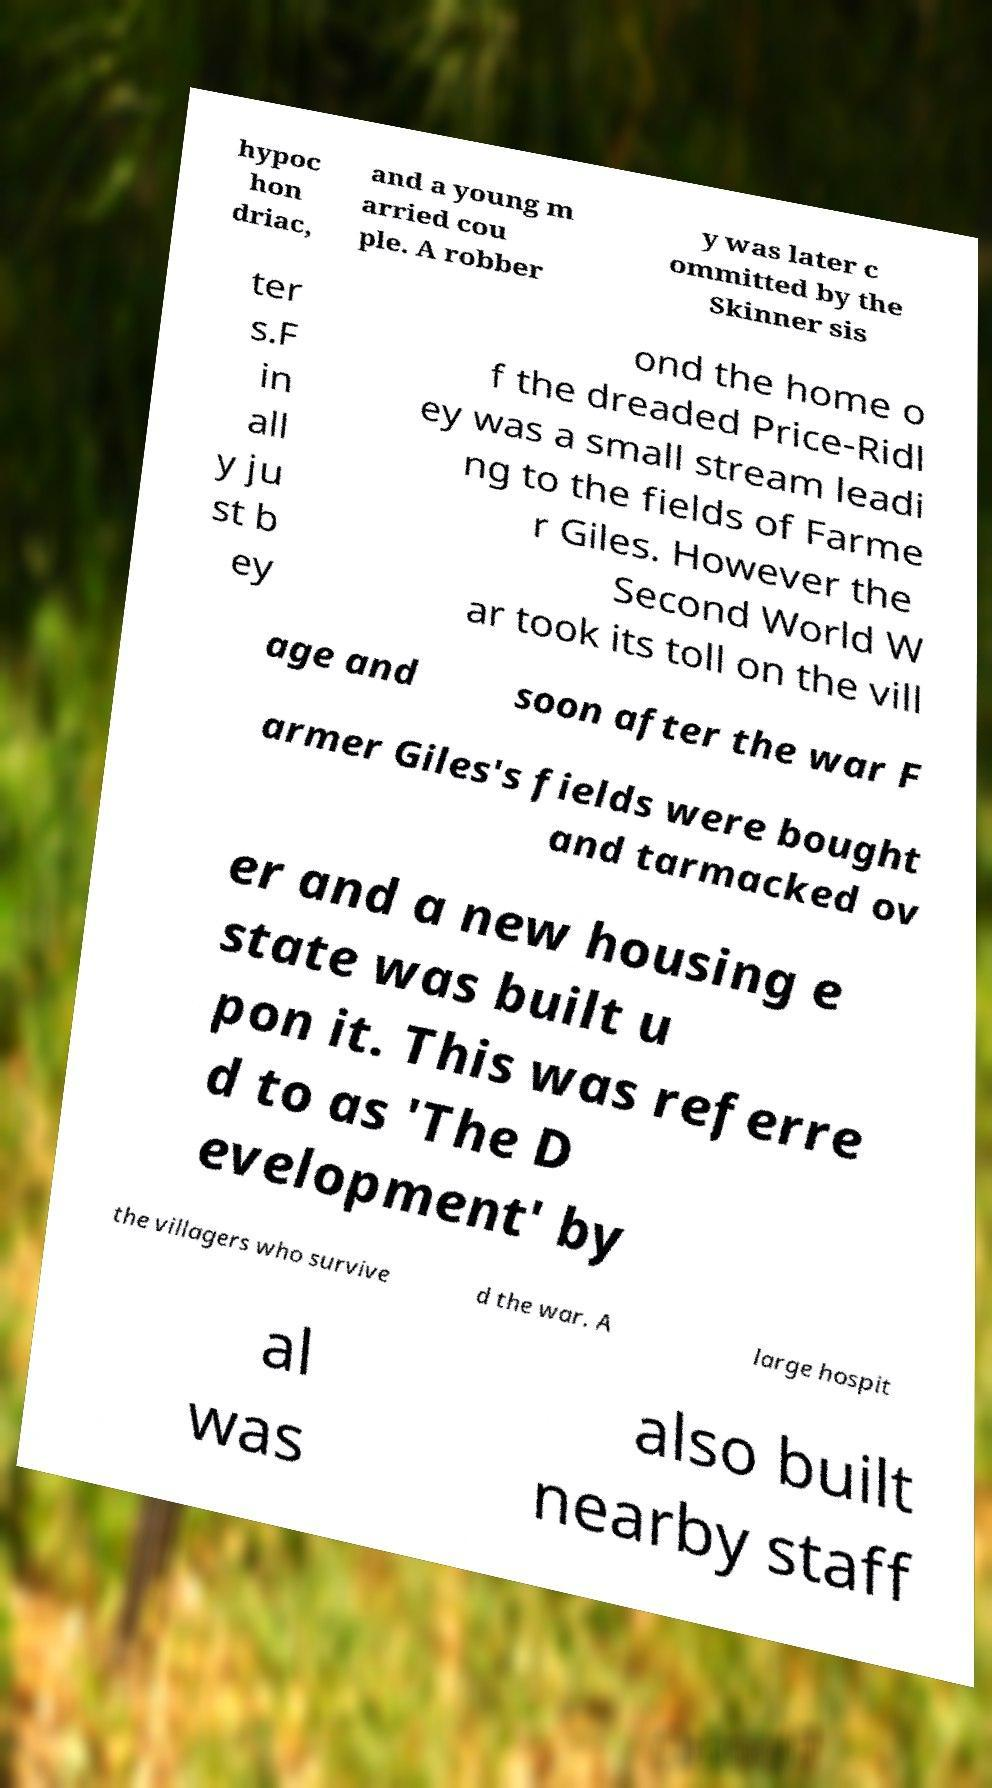What messages or text are displayed in this image? I need them in a readable, typed format. hypoc hon driac, and a young m arried cou ple. A robber y was later c ommitted by the Skinner sis ter s.F in all y ju st b ey ond the home o f the dreaded Price-Ridl ey was a small stream leadi ng to the fields of Farme r Giles. However the Second World W ar took its toll on the vill age and soon after the war F armer Giles's fields were bought and tarmacked ov er and a new housing e state was built u pon it. This was referre d to as 'The D evelopment' by the villagers who survive d the war. A large hospit al was also built nearby staff 